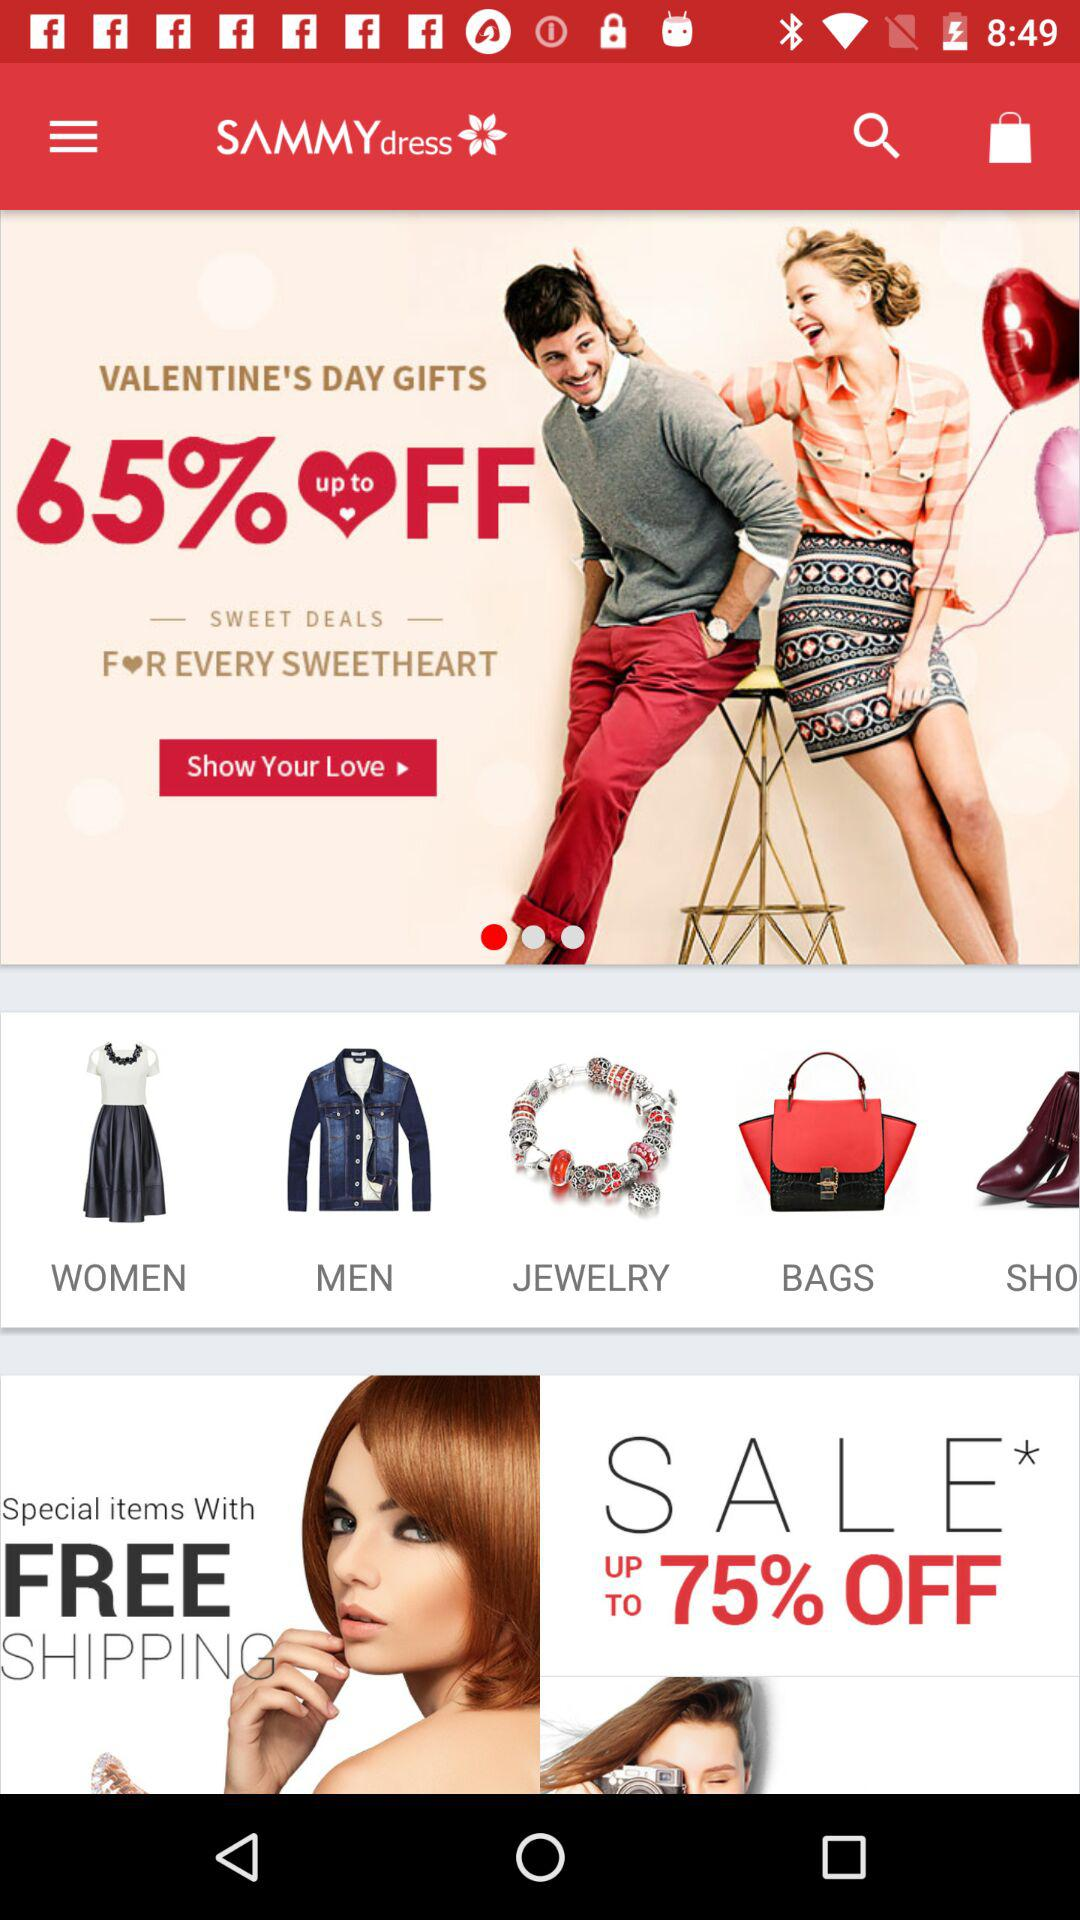How much is off on Valentine's Day gifts? There is up to 65% off on Valentine's Day gifts. 